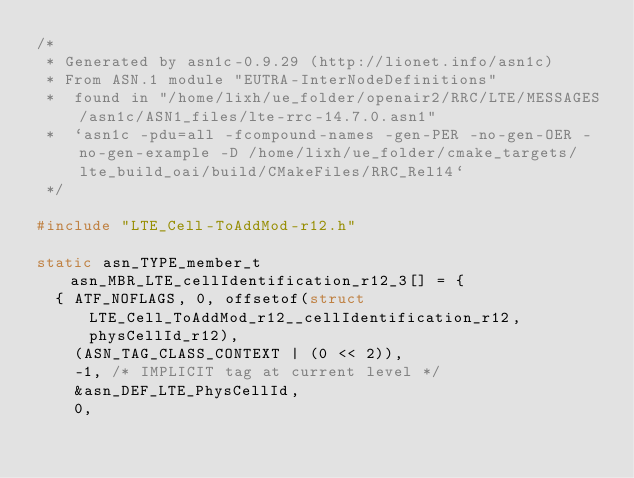<code> <loc_0><loc_0><loc_500><loc_500><_C_>/*
 * Generated by asn1c-0.9.29 (http://lionet.info/asn1c)
 * From ASN.1 module "EUTRA-InterNodeDefinitions"
 * 	found in "/home/lixh/ue_folder/openair2/RRC/LTE/MESSAGES/asn1c/ASN1_files/lte-rrc-14.7.0.asn1"
 * 	`asn1c -pdu=all -fcompound-names -gen-PER -no-gen-OER -no-gen-example -D /home/lixh/ue_folder/cmake_targets/lte_build_oai/build/CMakeFiles/RRC_Rel14`
 */

#include "LTE_Cell-ToAddMod-r12.h"

static asn_TYPE_member_t asn_MBR_LTE_cellIdentification_r12_3[] = {
	{ ATF_NOFLAGS, 0, offsetof(struct LTE_Cell_ToAddMod_r12__cellIdentification_r12, physCellId_r12),
		(ASN_TAG_CLASS_CONTEXT | (0 << 2)),
		-1,	/* IMPLICIT tag at current level */
		&asn_DEF_LTE_PhysCellId,
		0,</code> 